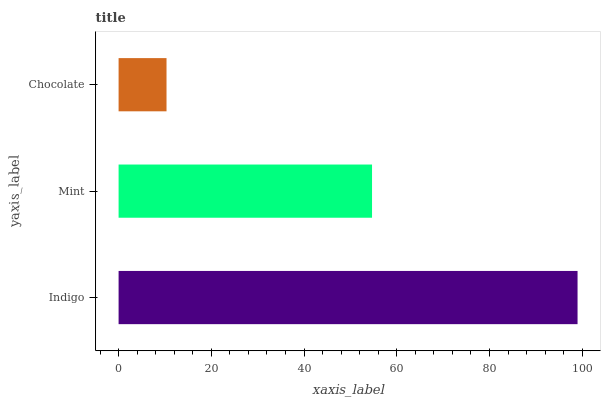Is Chocolate the minimum?
Answer yes or no. Yes. Is Indigo the maximum?
Answer yes or no. Yes. Is Mint the minimum?
Answer yes or no. No. Is Mint the maximum?
Answer yes or no. No. Is Indigo greater than Mint?
Answer yes or no. Yes. Is Mint less than Indigo?
Answer yes or no. Yes. Is Mint greater than Indigo?
Answer yes or no. No. Is Indigo less than Mint?
Answer yes or no. No. Is Mint the high median?
Answer yes or no. Yes. Is Mint the low median?
Answer yes or no. Yes. Is Indigo the high median?
Answer yes or no. No. Is Indigo the low median?
Answer yes or no. No. 